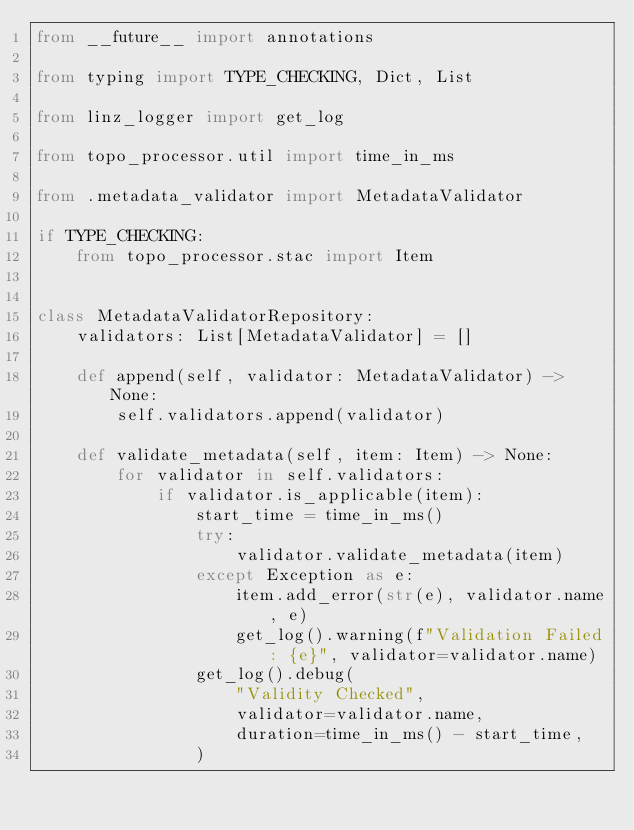Convert code to text. <code><loc_0><loc_0><loc_500><loc_500><_Python_>from __future__ import annotations

from typing import TYPE_CHECKING, Dict, List

from linz_logger import get_log

from topo_processor.util import time_in_ms

from .metadata_validator import MetadataValidator

if TYPE_CHECKING:
    from topo_processor.stac import Item


class MetadataValidatorRepository:
    validators: List[MetadataValidator] = []

    def append(self, validator: MetadataValidator) -> None:
        self.validators.append(validator)

    def validate_metadata(self, item: Item) -> None:
        for validator in self.validators:
            if validator.is_applicable(item):
                start_time = time_in_ms()
                try:
                    validator.validate_metadata(item)
                except Exception as e:
                    item.add_error(str(e), validator.name, e)
                    get_log().warning(f"Validation Failed: {e}", validator=validator.name)
                get_log().debug(
                    "Validity Checked",
                    validator=validator.name,
                    duration=time_in_ms() - start_time,
                )
</code> 